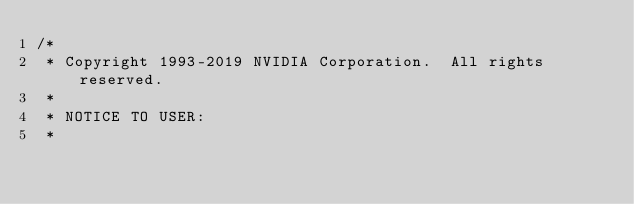<code> <loc_0><loc_0><loc_500><loc_500><_Cuda_>/*
 * Copyright 1993-2019 NVIDIA Corporation.  All rights reserved.
 *
 * NOTICE TO USER:
 *</code> 